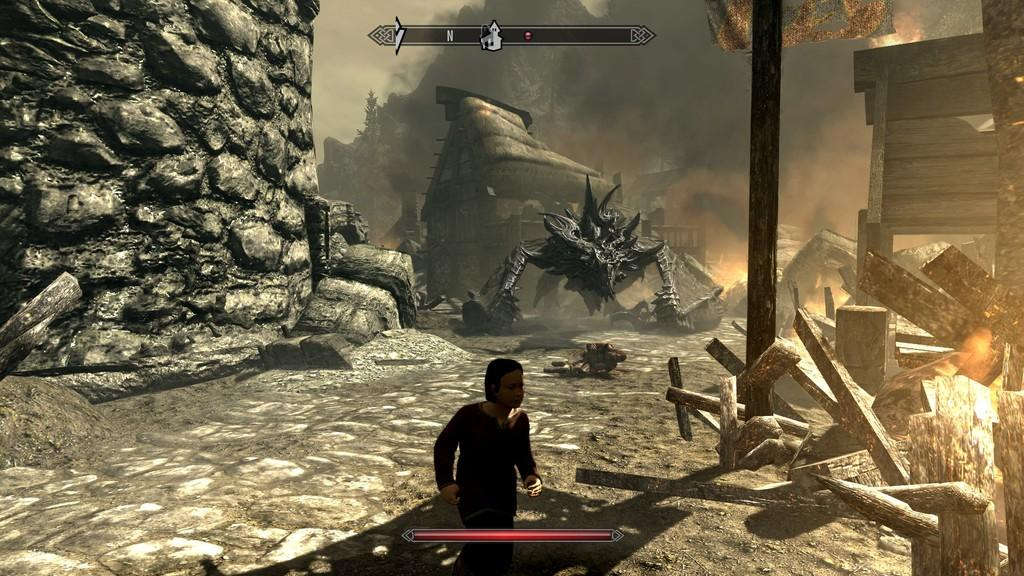What type of image is being described? The image is an animated picture. Can you describe the person at the bottom of the image? There is a person at the bottom of the image, but no specific details about their appearance or actions are provided. What can be seen in the background of the image? In the background of the image, there are houses, rocks, wood, and smoke. How many elements can be identified in the background of the image? There are four elements in the background of the image: houses, rocks, wood, and smoke. What type of comb is being used by the person in the image? There is no comb present in the image, and no person is shown using one. 